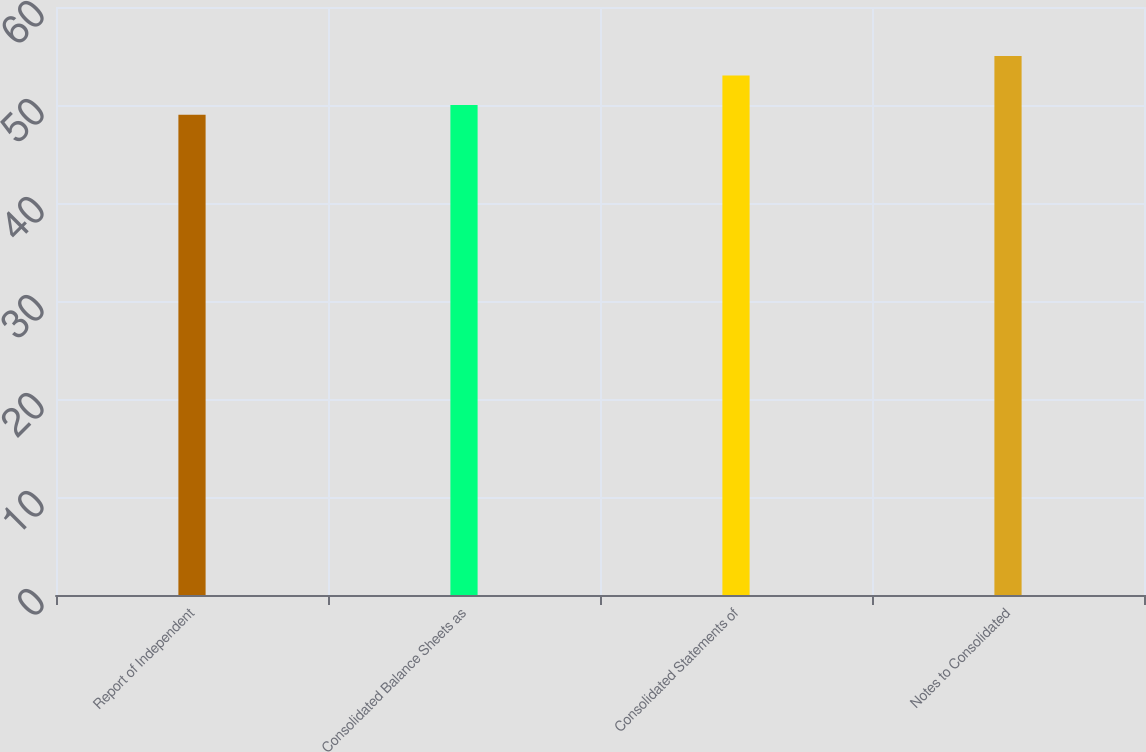Convert chart to OTSL. <chart><loc_0><loc_0><loc_500><loc_500><bar_chart><fcel>Report of Independent<fcel>Consolidated Balance Sheets as<fcel>Consolidated Statements of<fcel>Notes to Consolidated<nl><fcel>49<fcel>50<fcel>53<fcel>55<nl></chart> 